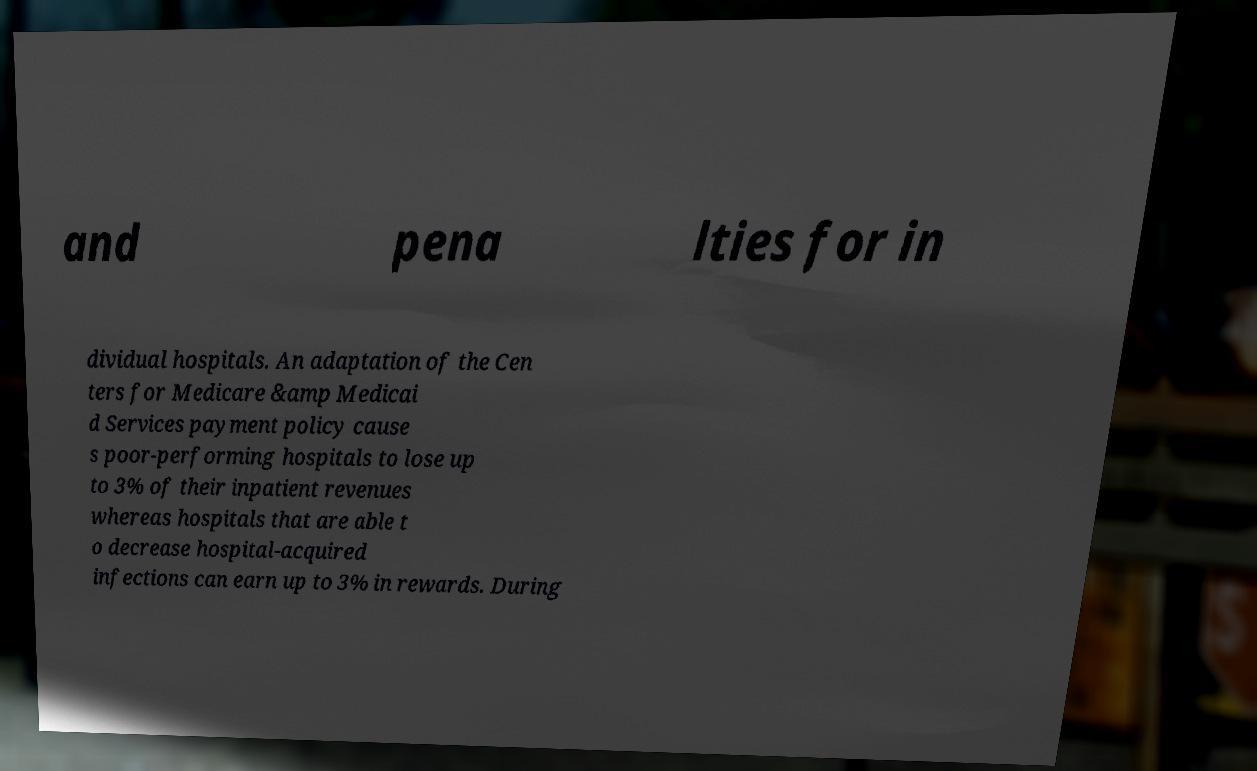Can you accurately transcribe the text from the provided image for me? and pena lties for in dividual hospitals. An adaptation of the Cen ters for Medicare &amp Medicai d Services payment policy cause s poor-performing hospitals to lose up to 3% of their inpatient revenues whereas hospitals that are able t o decrease hospital-acquired infections can earn up to 3% in rewards. During 